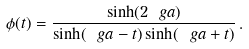Convert formula to latex. <formula><loc_0><loc_0><loc_500><loc_500>\phi ( t ) = \frac { \sinh ( 2 \ g a ) } { \sinh ( \ g a - t ) \sinh ( \ g a + t ) } \, .</formula> 